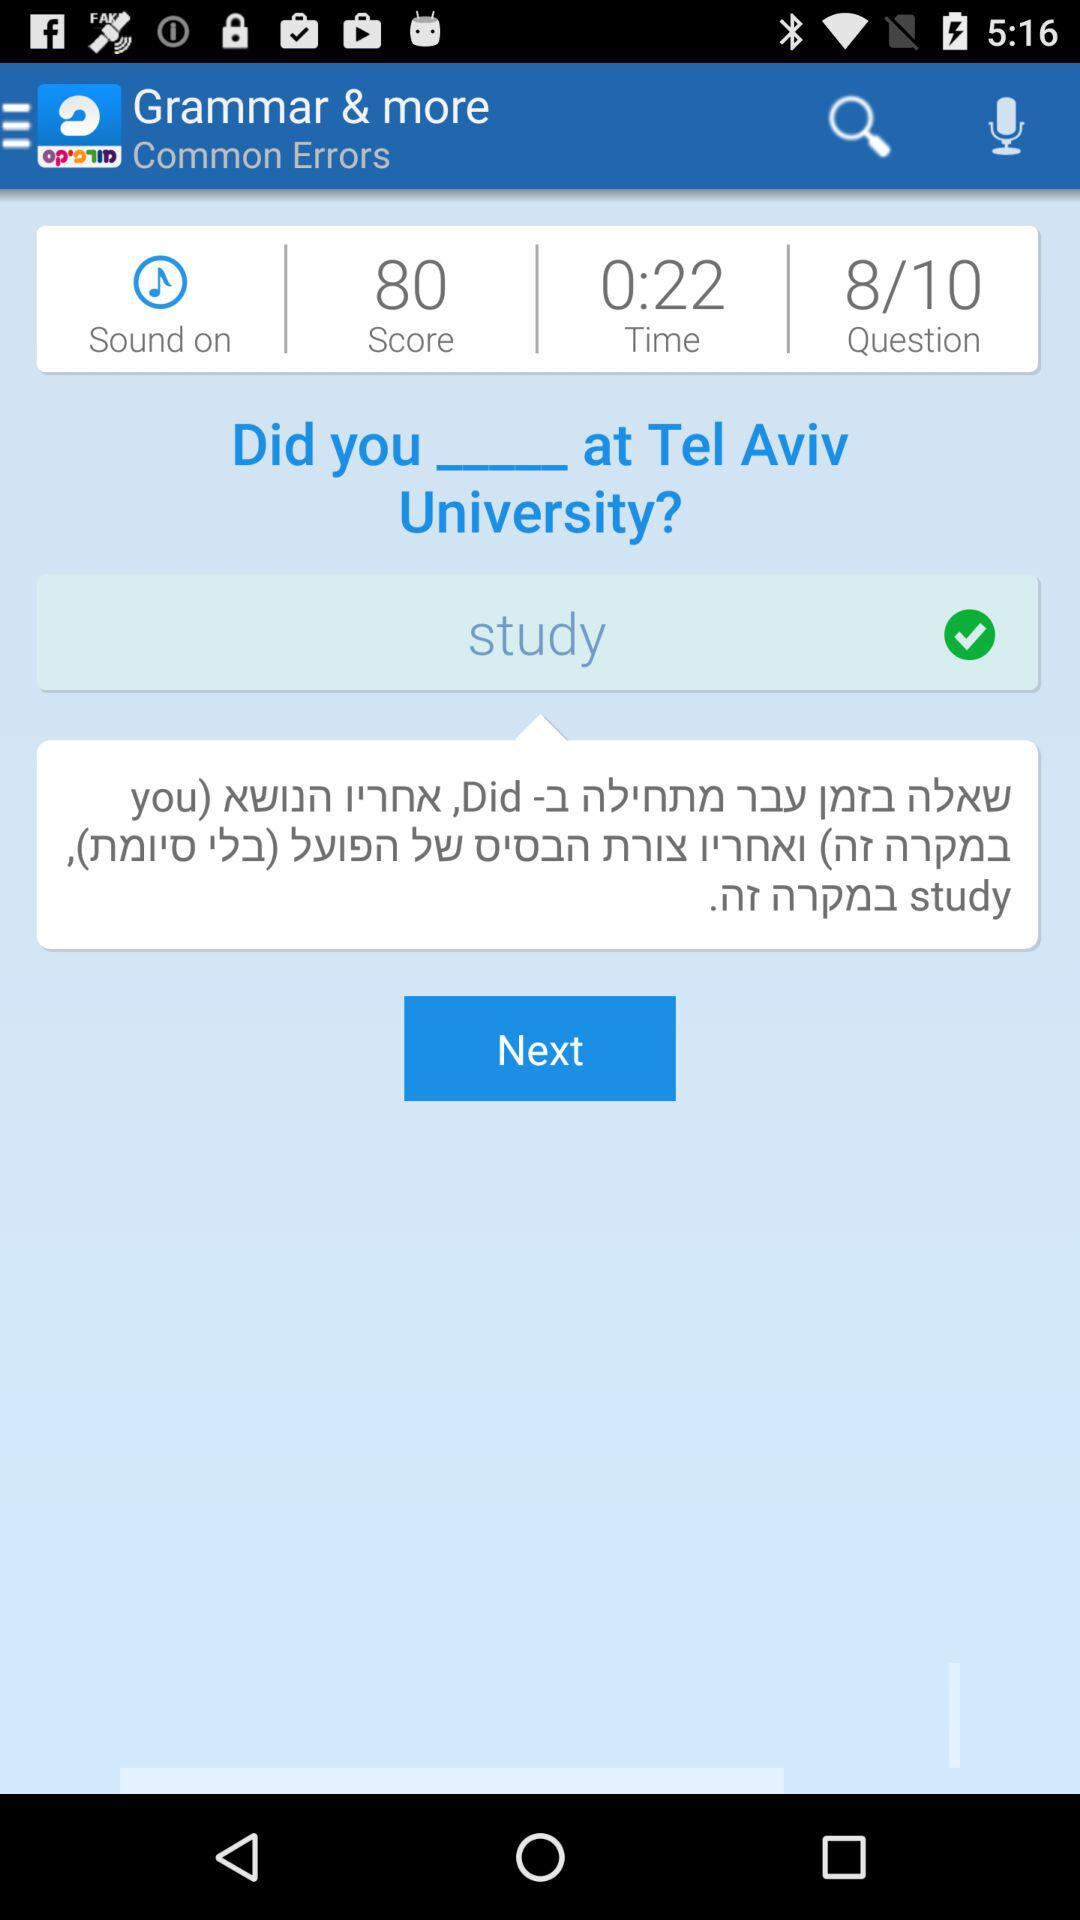What is the status of the "Sound"? The status is "on". 